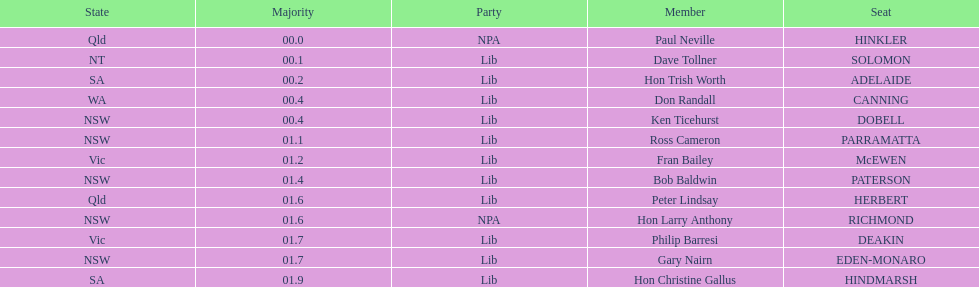What party had the most seats? Lib. 